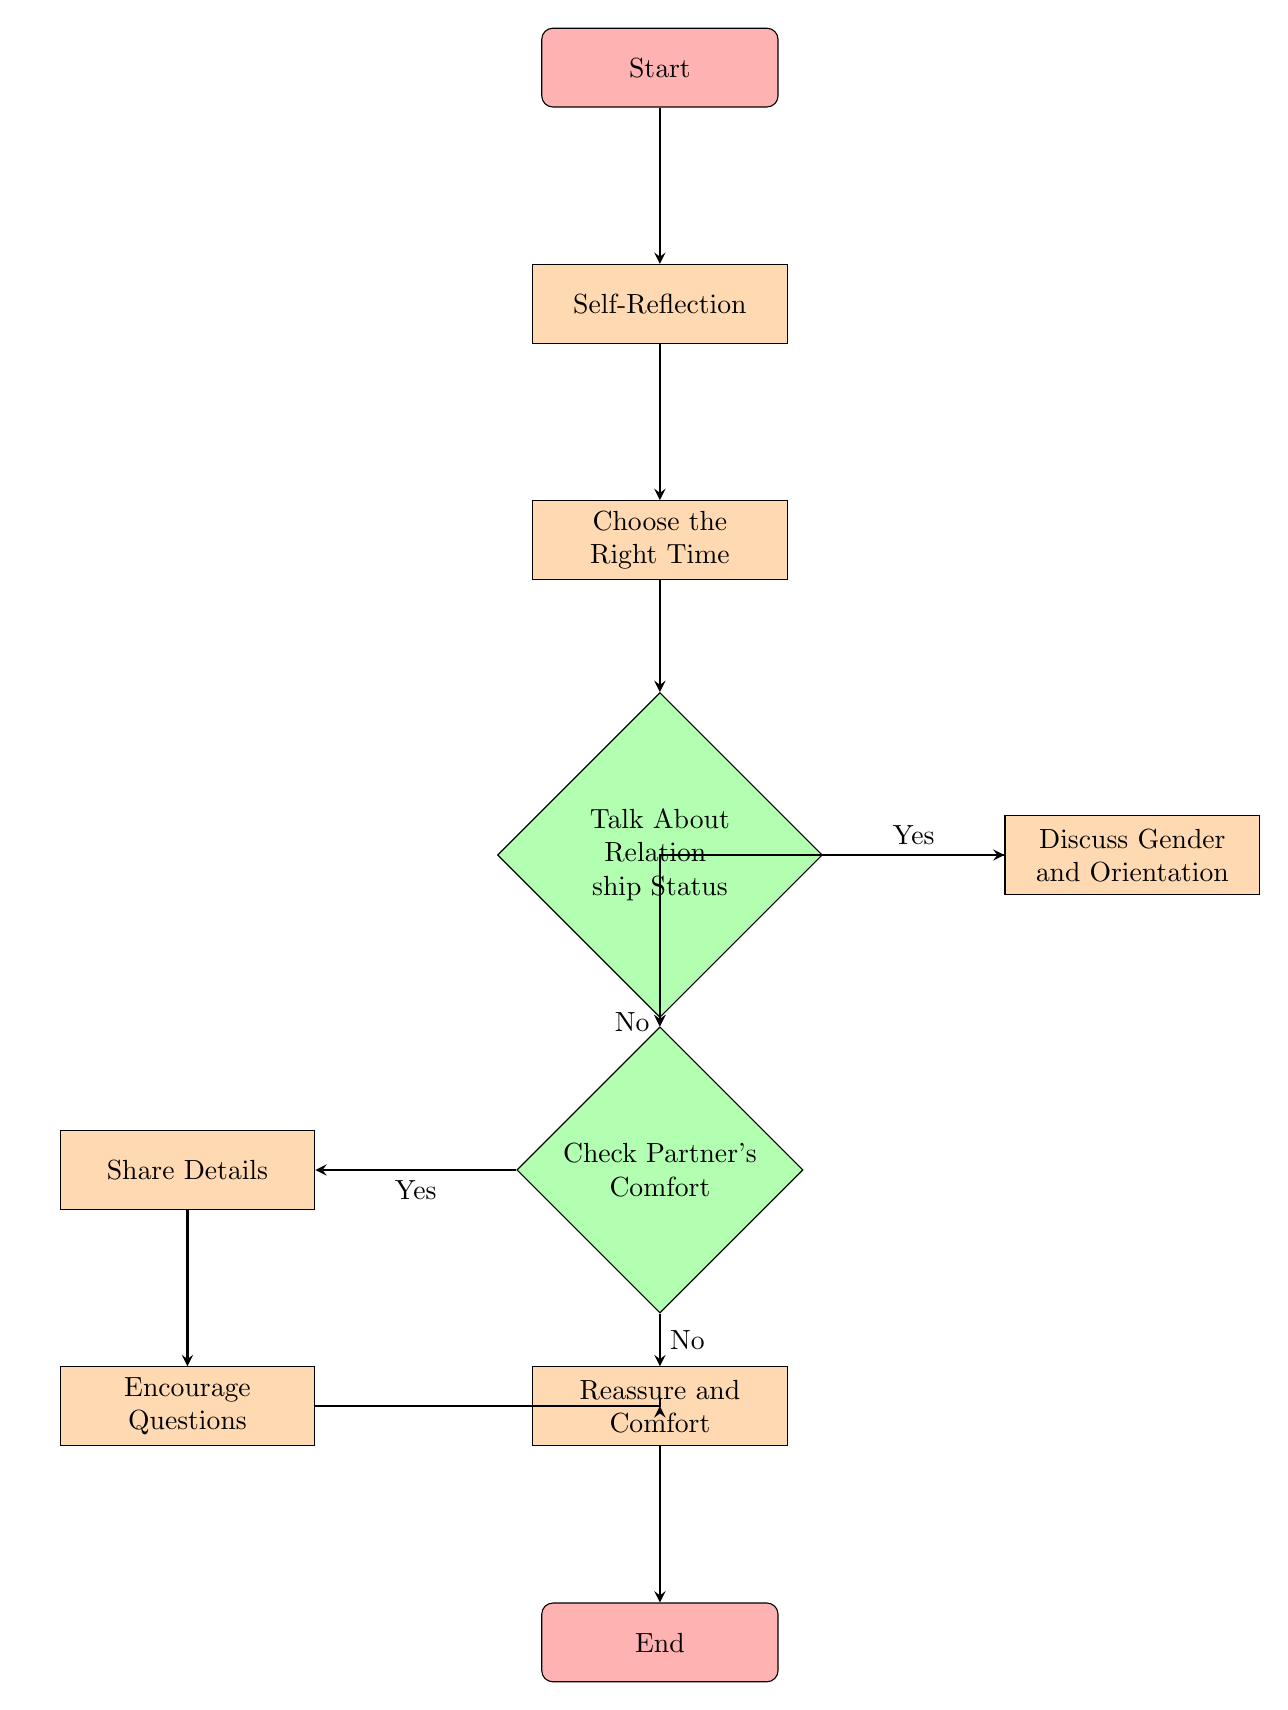What is the first step in the flowchart? The first step in the flowchart is represented by the initial node labeled "Start." This node serves as the entry point of the process, indicating where navigation begins.
Answer: Start How many process nodes are in the diagram? The diagram contains four process nodes: "Self-Reflection," "Choose the Right Time," "Discuss Gender and Orientation," "Share Details," "Encourage Questions," and "Reassure and Comfort." Counting these shows there are six process nodes in total.
Answer: Six What happens if the answer to the relationship status is "No"? If the answer to "Talk About Relationship Status" is "No," the flow proceeds to the "Check Partner's Comfort" decision node. This means the discussion about relationship status does not continue to the next process but instead checks on the partner’s feelings about the conversation.
Answer: Check Partner's Comfort What is the last process before the flowchart ends? The last process before reaching the endpoint labeled "End" is "Reassure and Comfort." This is the final process where the partner needs reassurance before concluding the conversation.
Answer: Reassure and Comfort What node comes before "Share Details"? The node that comes before "Share Details" is "Check Partner's Comfort." This indicates that there needs to be a determination of the partner's comfort level before any details are shared about past relationships.
Answer: Check Partner's Comfort 